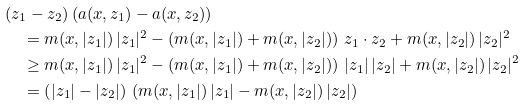<formula> <loc_0><loc_0><loc_500><loc_500>& ( z _ { 1 } - z _ { 2 } ) \, ( a ( x , z _ { 1 } ) - a ( x , z _ { 2 } ) ) \\ & \quad = m ( x , | z _ { 1 } | ) \, | z _ { 1 } | ^ { 2 } - \left ( m ( x , | z _ { 1 } | ) + m ( x , | z _ { 2 } | ) \right ) \, z _ { 1 } \cdot z _ { 2 } + m ( x , | z _ { 2 } | ) \, | z _ { 2 } | ^ { 2 } \\ & \quad \geq m ( x , | z _ { 1 } | ) \, | z _ { 1 } | ^ { 2 } - \left ( m ( x , | z _ { 1 } | ) + m ( x , | z _ { 2 } | ) \right ) \, | z _ { 1 } | \, | z _ { 2 } | + m ( x , | z _ { 2 } | ) \, | z _ { 2 } | ^ { 2 } \\ & \quad = \left ( | z _ { 1 } | - | z _ { 2 } | \right ) \, \left ( m ( x , | z _ { 1 } | ) \, | z _ { 1 } | - m ( x , | z _ { 2 } | ) \, | z _ { 2 } | \right )</formula> 